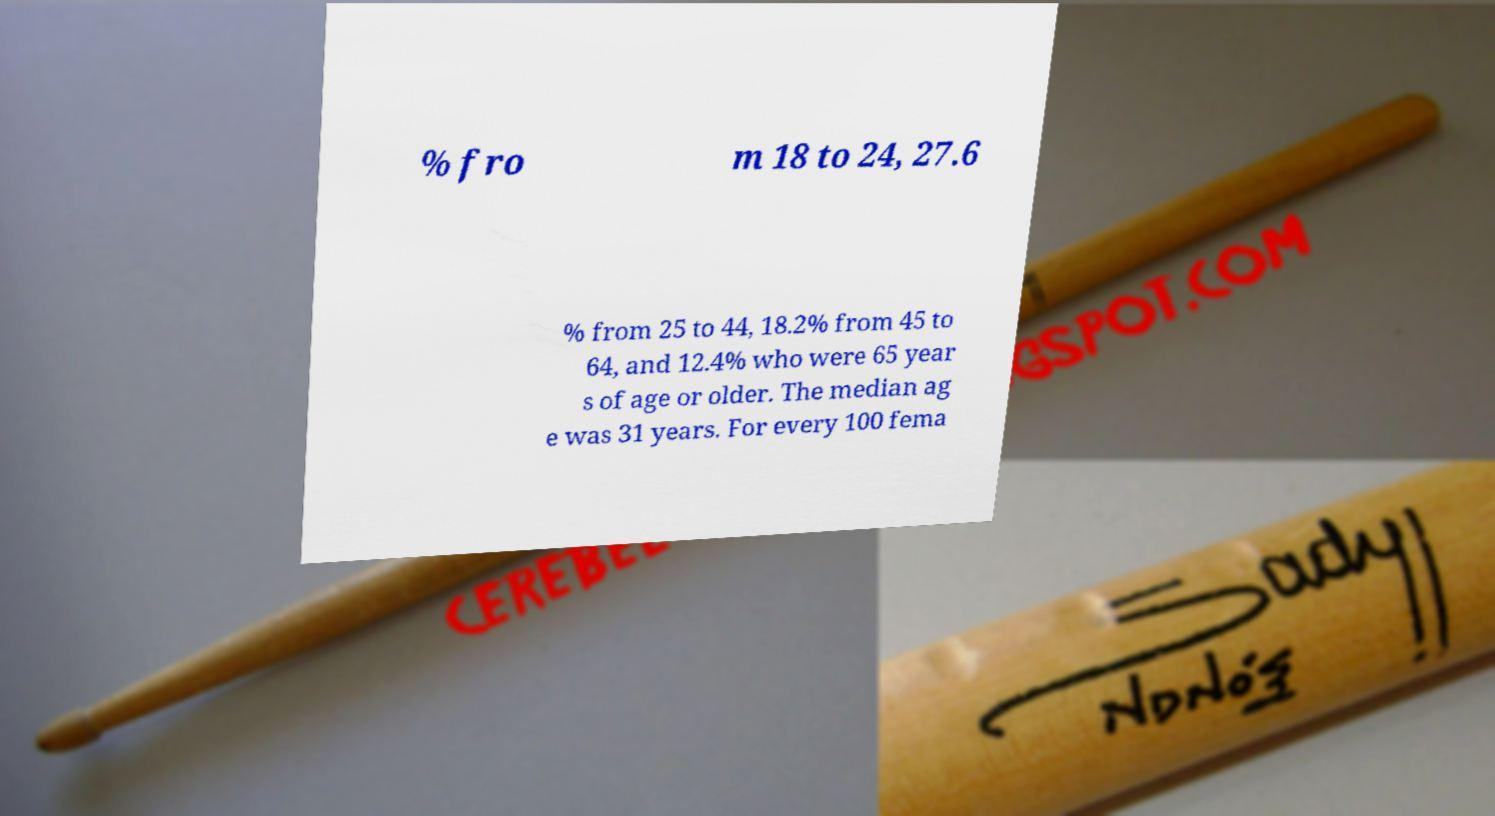Could you assist in decoding the text presented in this image and type it out clearly? % fro m 18 to 24, 27.6 % from 25 to 44, 18.2% from 45 to 64, and 12.4% who were 65 year s of age or older. The median ag e was 31 years. For every 100 fema 